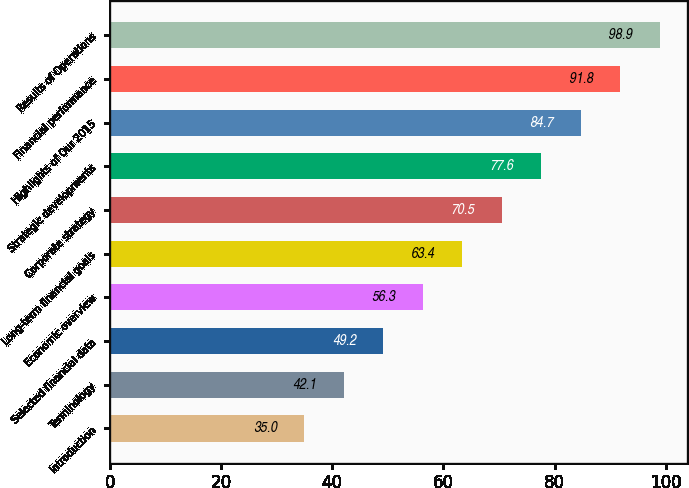Convert chart to OTSL. <chart><loc_0><loc_0><loc_500><loc_500><bar_chart><fcel>Introduction<fcel>Terminology<fcel>Selected financial data<fcel>Economic overview<fcel>Long-term financial goals<fcel>Corporate strategy<fcel>Strategic developments<fcel>Highlights of Our 2015<fcel>Financial performance<fcel>Results of Operations<nl><fcel>35<fcel>42.1<fcel>49.2<fcel>56.3<fcel>63.4<fcel>70.5<fcel>77.6<fcel>84.7<fcel>91.8<fcel>98.9<nl></chart> 